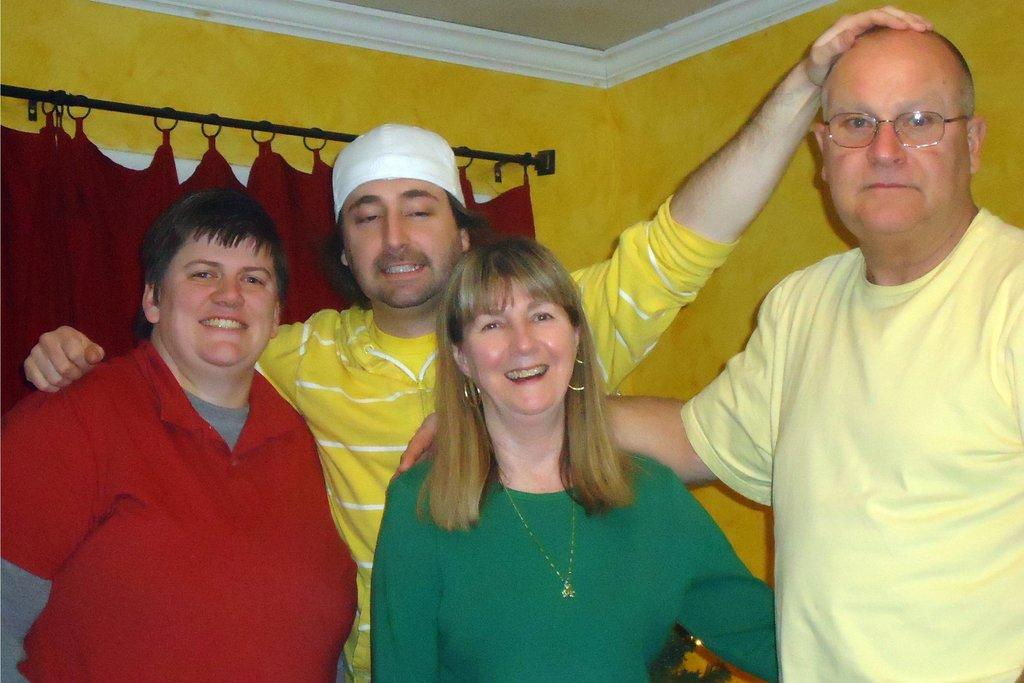How many people are in the image? There are persons in the image, but the exact number is not specified. What is the color of the wall behind the persons? There is a yellow color wall visible behind the persons. What type of fabric is used for the curtain in the image? There is a maroon color curtain in the image. What type of feather can be seen on the shoes of the persons in the image? There is no mention of shoes or feathers in the image, so it cannot be determined if any feathers are present. 